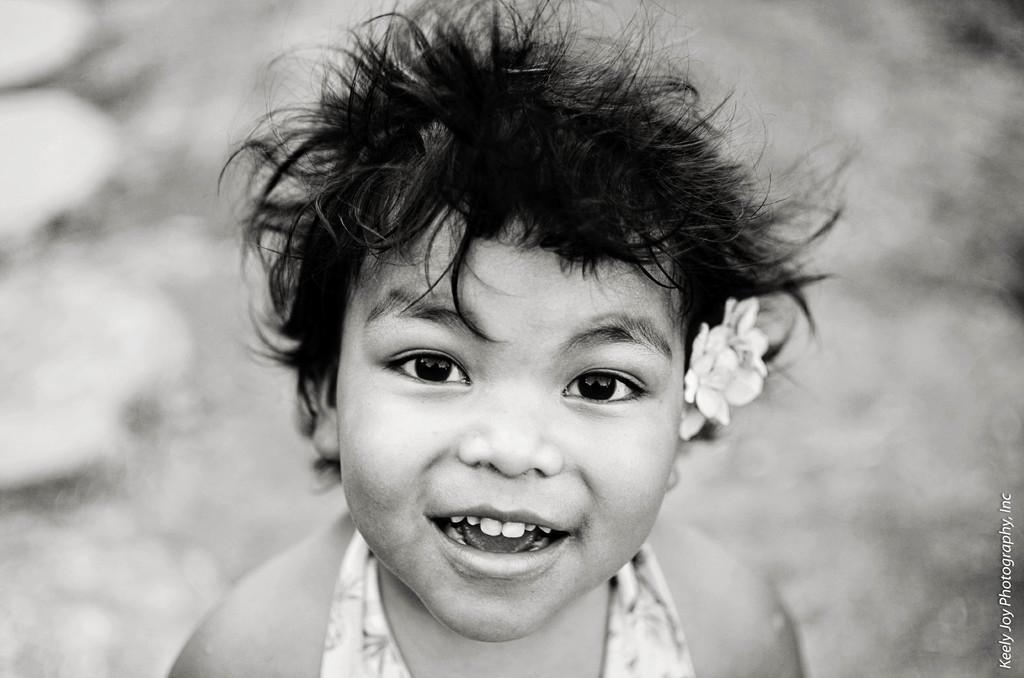Who is the main subject in the image? There is a girl in the image. What is the girl's expression? The girl is smiling. Can you describe any objects or elements near the girl? There is a flower near the girl's hair on the right side. Where is the text located in the image? There is text in the bottom right corner of the image. What type of curtain is covering the girl's face in the image? There is no curtain present in the image, and the girl's face is not covered. 